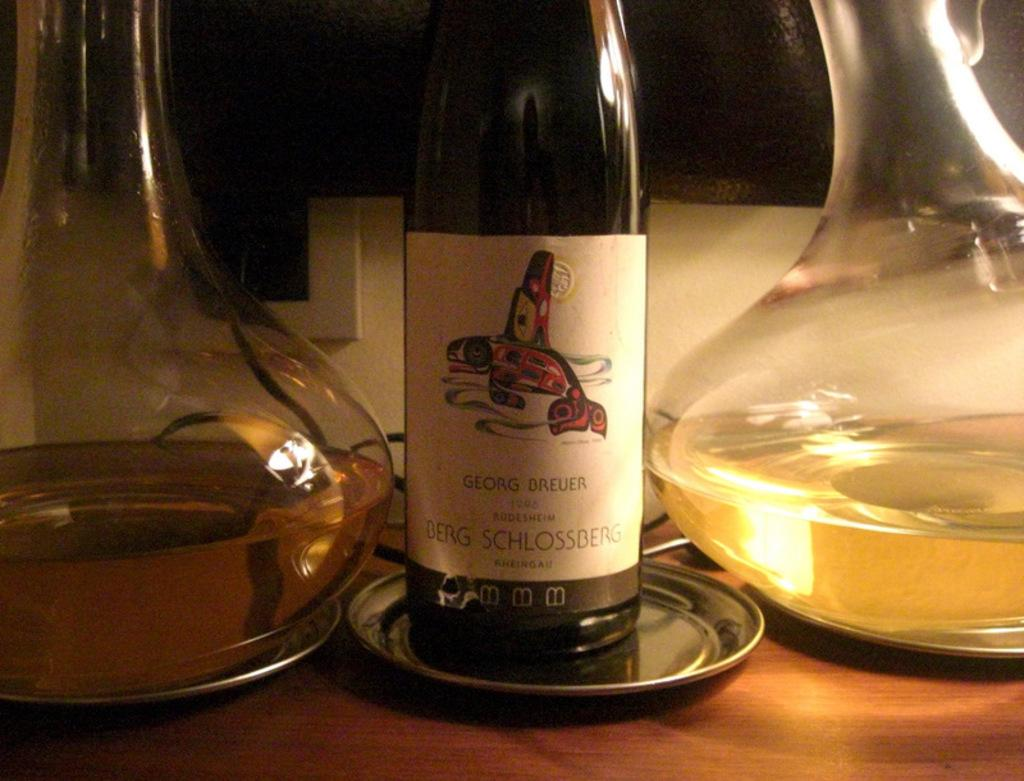Provide a one-sentence caption for the provided image. A bottle of Georg Brueuer wine sits on a table next to two decanters of wine. 